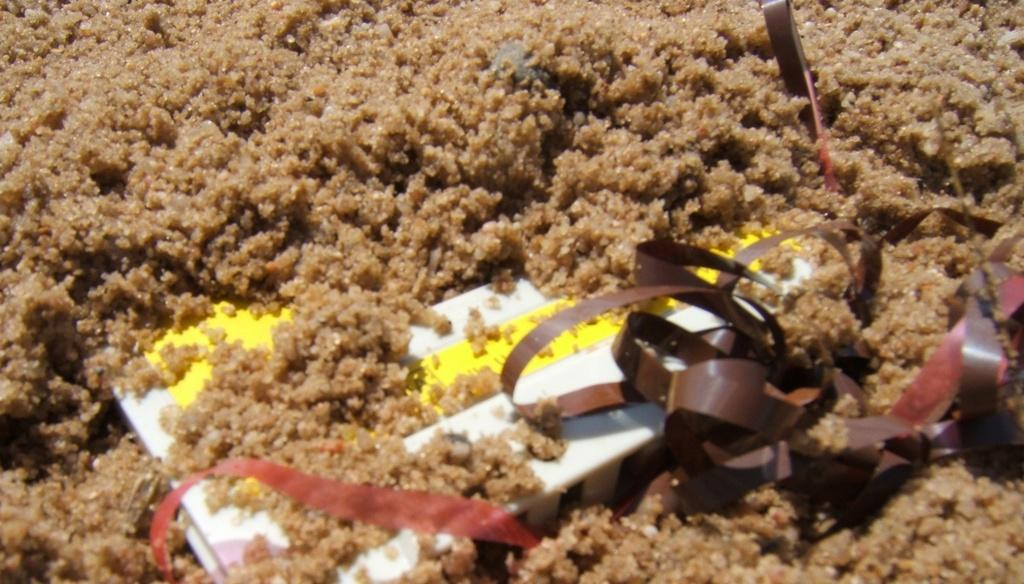What is the main color of the object in the image? The main color of the object in the image is brown. What can be found inside the brown object? There is a white and yellow color box inside the brown object. Are there any other brown objects in the image? Yes, there are brown color ribbons in the image. How does the engine function in the image? There is no engine present in the image. 